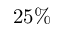<formula> <loc_0><loc_0><loc_500><loc_500>2 5 \%</formula> 